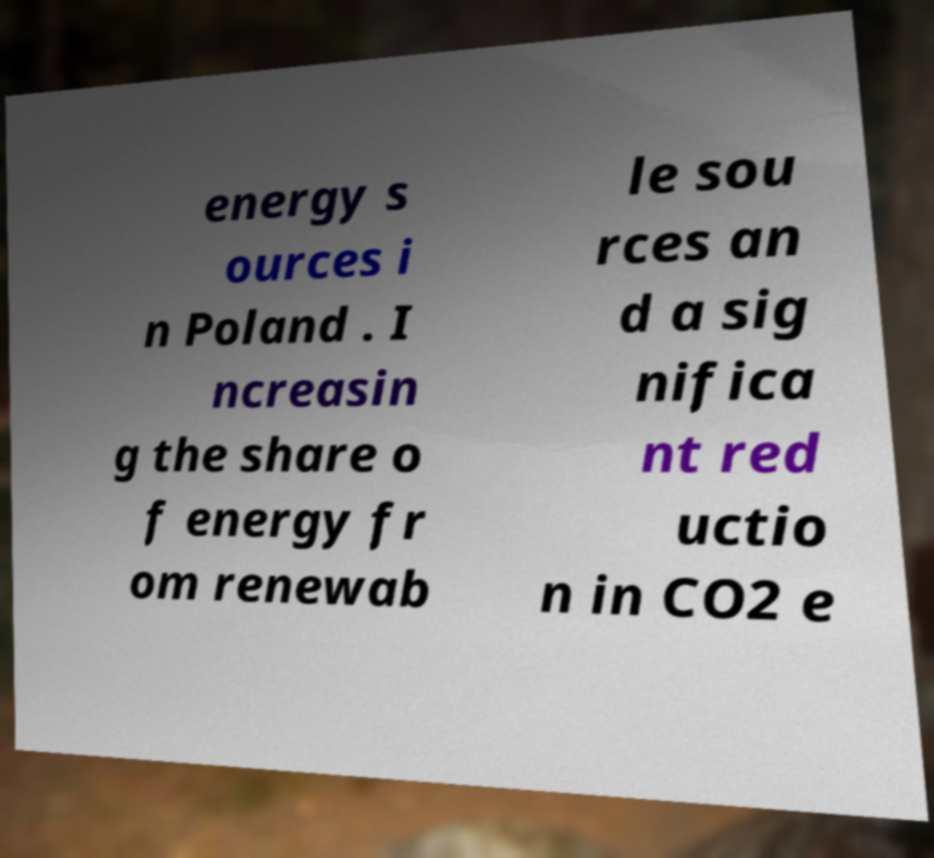For documentation purposes, I need the text within this image transcribed. Could you provide that? energy s ources i n Poland . I ncreasin g the share o f energy fr om renewab le sou rces an d a sig nifica nt red uctio n in CO2 e 